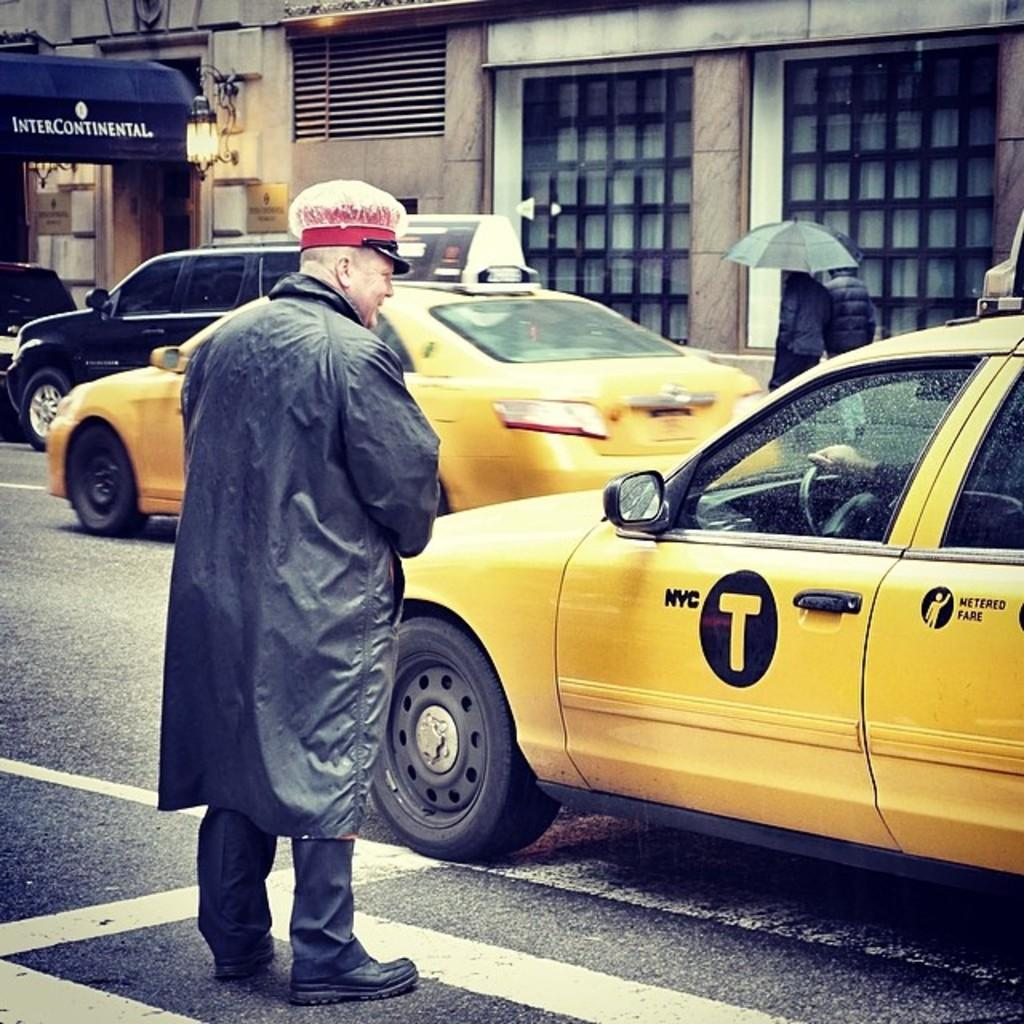<image>
Write a terse but informative summary of the picture. A man standing in the street talking to a person in a cab labeled NYC T. 